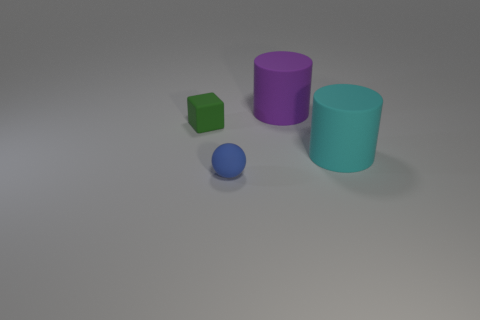Add 3 tiny cyan metallic cubes. How many objects exist? 7 Subtract all cubes. How many objects are left? 3 Subtract 0 cyan balls. How many objects are left? 4 Subtract all large cylinders. Subtract all large cyan matte cylinders. How many objects are left? 1 Add 1 cyan matte cylinders. How many cyan matte cylinders are left? 2 Add 1 tiny blue things. How many tiny blue things exist? 2 